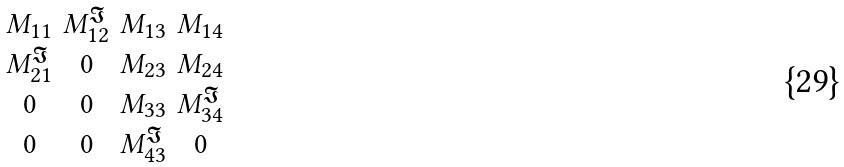<formula> <loc_0><loc_0><loc_500><loc_500>\begin{smallmatrix} \\ M _ { 1 1 } & M _ { 1 2 } ^ { \Im } & M _ { 1 3 } & M _ { 1 4 } \\ M _ { 2 1 } ^ { \Im } & 0 & M _ { 2 3 } & M _ { 2 4 } \\ 0 & 0 & M _ { 3 3 } & M _ { 3 4 } ^ { \Im } \\ 0 & 0 & M _ { 4 3 } ^ { \Im } & 0 \\ \end{smallmatrix}</formula> 